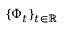Convert formula to latex. <formula><loc_0><loc_0><loc_500><loc_500>\{ \Phi _ { t } \} _ { t \in \mathbb { R } }</formula> 